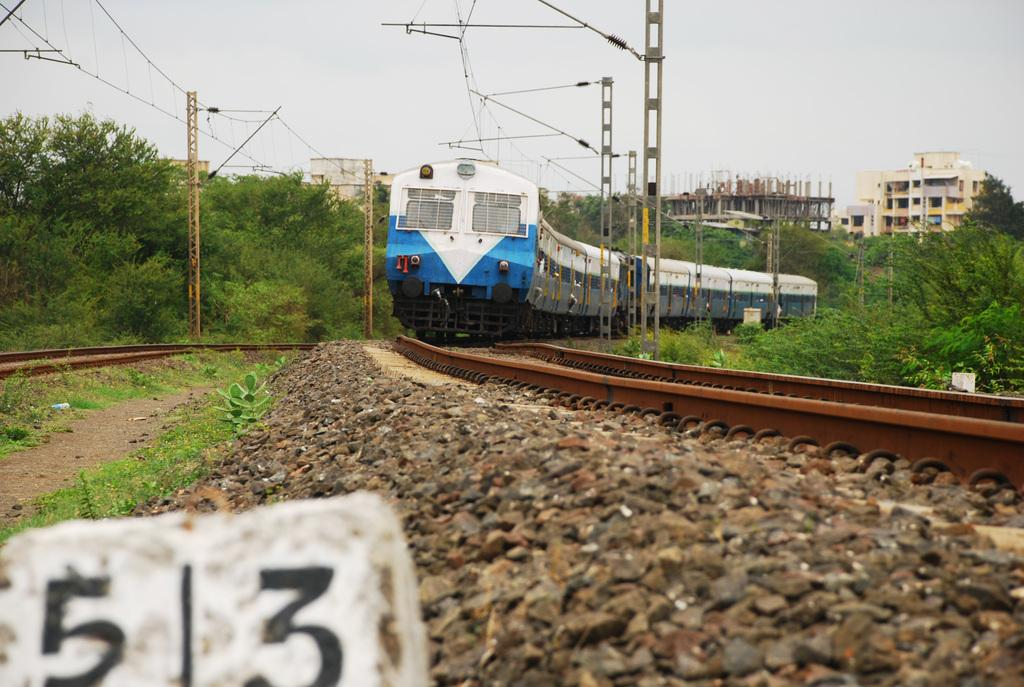<image>
Write a terse but informative summary of the picture. A train is pulling up to marker 513. 